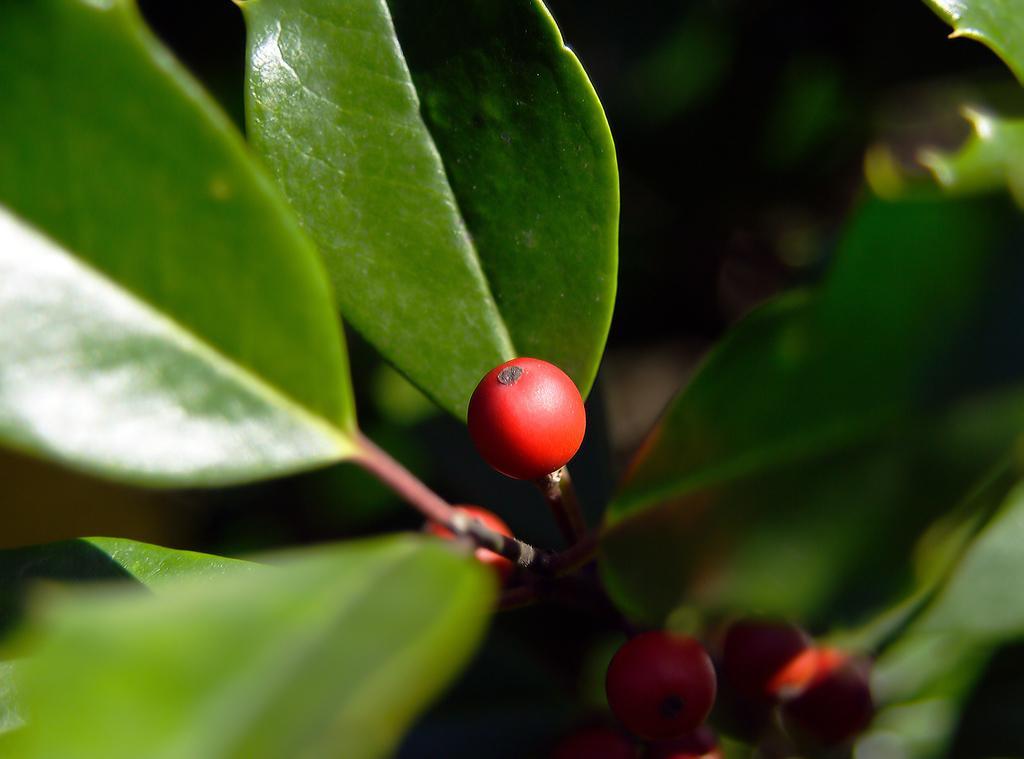Please provide a concise description of this image. In the image there are small red color fruits to a plant and the background of the plant is blur. 